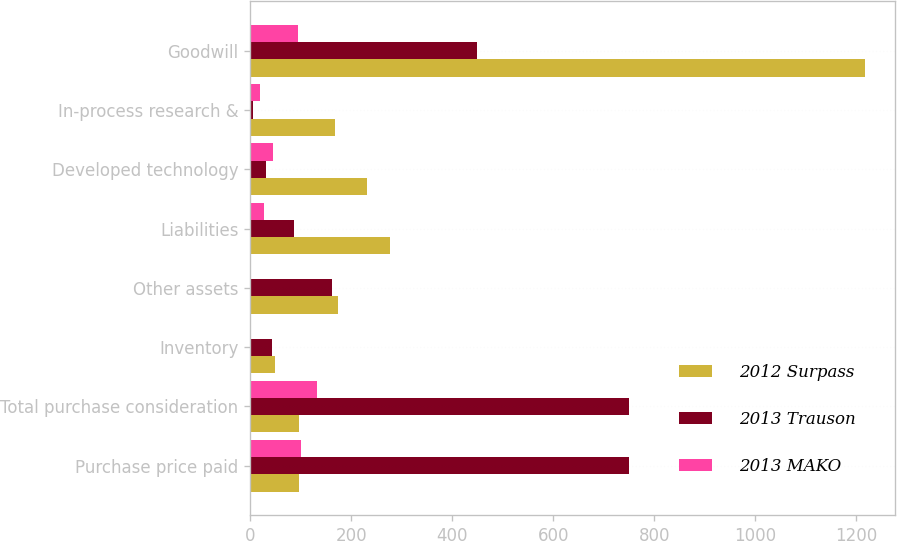Convert chart. <chart><loc_0><loc_0><loc_500><loc_500><stacked_bar_chart><ecel><fcel>Purchase price paid<fcel>Total purchase consideration<fcel>Inventory<fcel>Other assets<fcel>Liabilities<fcel>Developed technology<fcel>In-process research &<fcel>Goodwill<nl><fcel>2012 Surpass<fcel>97<fcel>97<fcel>50<fcel>174<fcel>277<fcel>231<fcel>169<fcel>1217<nl><fcel>2013 Trauson<fcel>751<fcel>751<fcel>43<fcel>163<fcel>87<fcel>31<fcel>5<fcel>450<nl><fcel>2013 MAKO<fcel>100<fcel>133<fcel>2<fcel>1<fcel>28<fcel>45<fcel>19<fcel>94<nl></chart> 